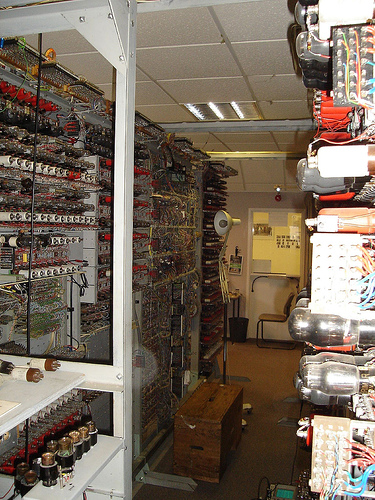<image>
Is there a lamp on the box? No. The lamp is not positioned on the box. They may be near each other, but the lamp is not supported by or resting on top of the box. 